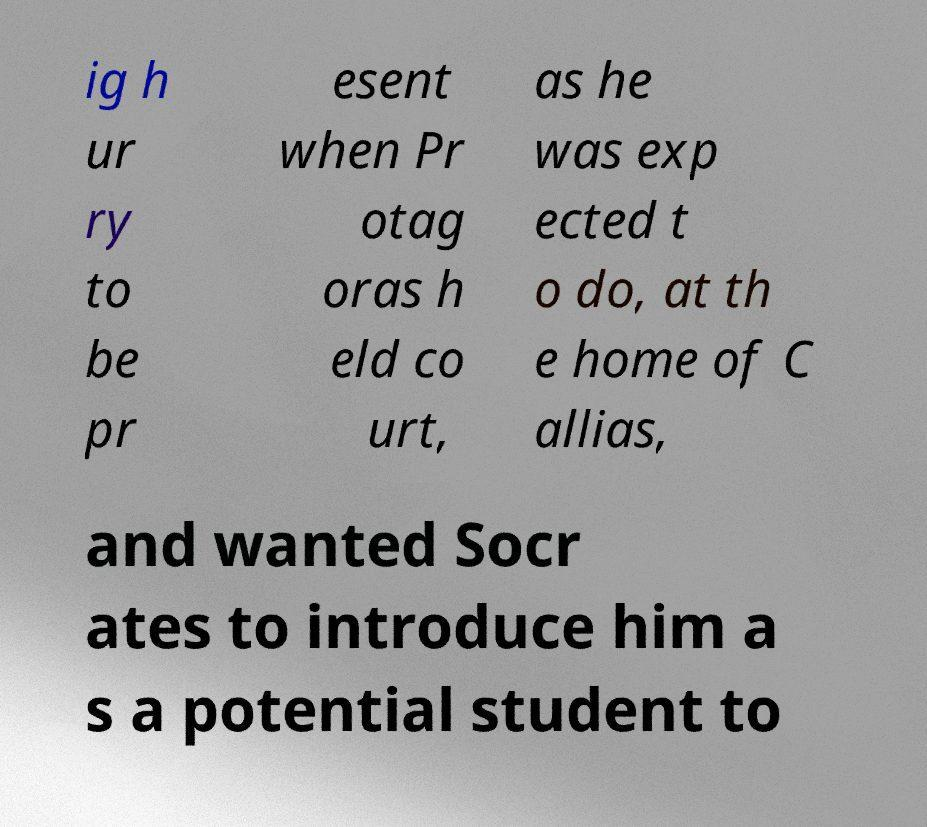There's text embedded in this image that I need extracted. Can you transcribe it verbatim? ig h ur ry to be pr esent when Pr otag oras h eld co urt, as he was exp ected t o do, at th e home of C allias, and wanted Socr ates to introduce him a s a potential student to 